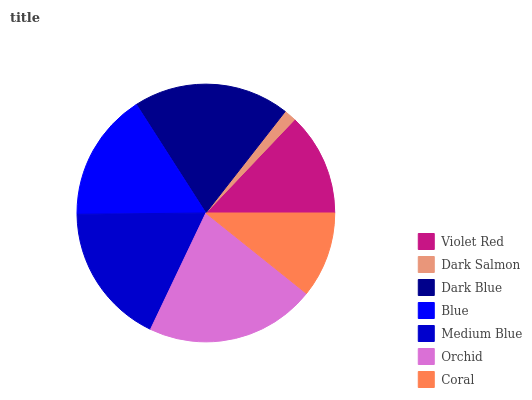Is Dark Salmon the minimum?
Answer yes or no. Yes. Is Orchid the maximum?
Answer yes or no. Yes. Is Dark Blue the minimum?
Answer yes or no. No. Is Dark Blue the maximum?
Answer yes or no. No. Is Dark Blue greater than Dark Salmon?
Answer yes or no. Yes. Is Dark Salmon less than Dark Blue?
Answer yes or no. Yes. Is Dark Salmon greater than Dark Blue?
Answer yes or no. No. Is Dark Blue less than Dark Salmon?
Answer yes or no. No. Is Blue the high median?
Answer yes or no. Yes. Is Blue the low median?
Answer yes or no. Yes. Is Violet Red the high median?
Answer yes or no. No. Is Violet Red the low median?
Answer yes or no. No. 